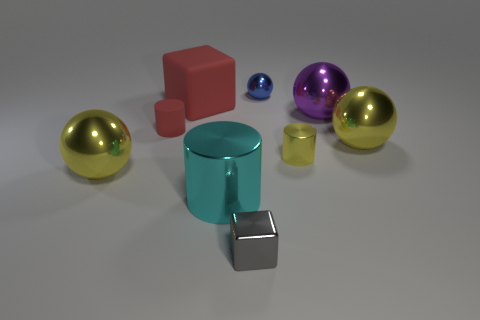Does the gray metal object have the same size as the cyan metallic object?
Offer a very short reply. No. What color is the tiny sphere that is made of the same material as the yellow cylinder?
Your response must be concise. Blue. There is a large rubber thing that is the same color as the small matte object; what is its shape?
Offer a terse response. Cube. Is the number of large matte objects that are on the right side of the purple shiny sphere the same as the number of small metallic objects that are behind the small metallic block?
Make the answer very short. No. There is a gray object on the right side of the big yellow metal object to the left of the gray thing; what is its shape?
Your response must be concise. Cube. There is a small blue thing that is the same shape as the large purple shiny thing; what material is it?
Provide a succinct answer. Metal. What is the color of the block that is the same size as the blue metal sphere?
Provide a succinct answer. Gray. Are there the same number of large red matte blocks to the right of the purple thing and cylinders?
Your answer should be compact. No. There is a cube behind the cylinder to the right of the big cyan metal cylinder; what color is it?
Your response must be concise. Red. What is the size of the cylinder that is in front of the yellow object to the left of the small blue metal sphere?
Offer a terse response. Large. 